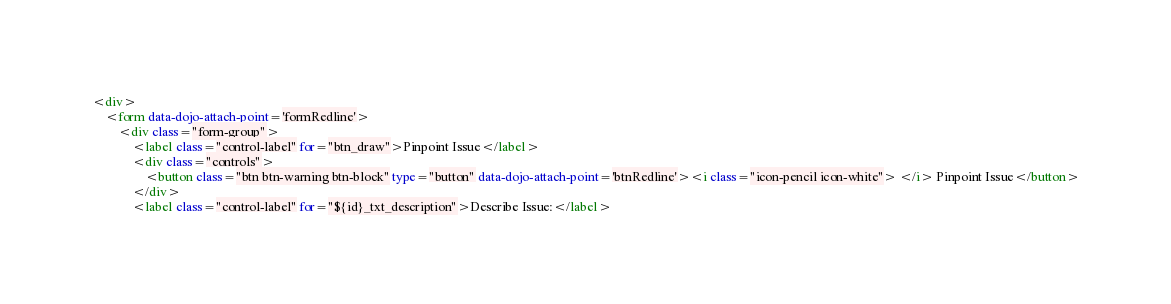<code> <loc_0><loc_0><loc_500><loc_500><_HTML_><div>
    <form data-dojo-attach-point='formRedline'>
        <div class="form-group">
            <label class="control-label" for="btn_draw">Pinpoint Issue</label>
            <div class="controls">
                <button class="btn btn-warning btn-block" type="button" data-dojo-attach-point='btnRedline'><i class="icon-pencil icon-white"> </i> Pinpoint Issue</button>
            </div>
            <label class="control-label" for="${id}_txt_description">Describe Issue:</label></code> 